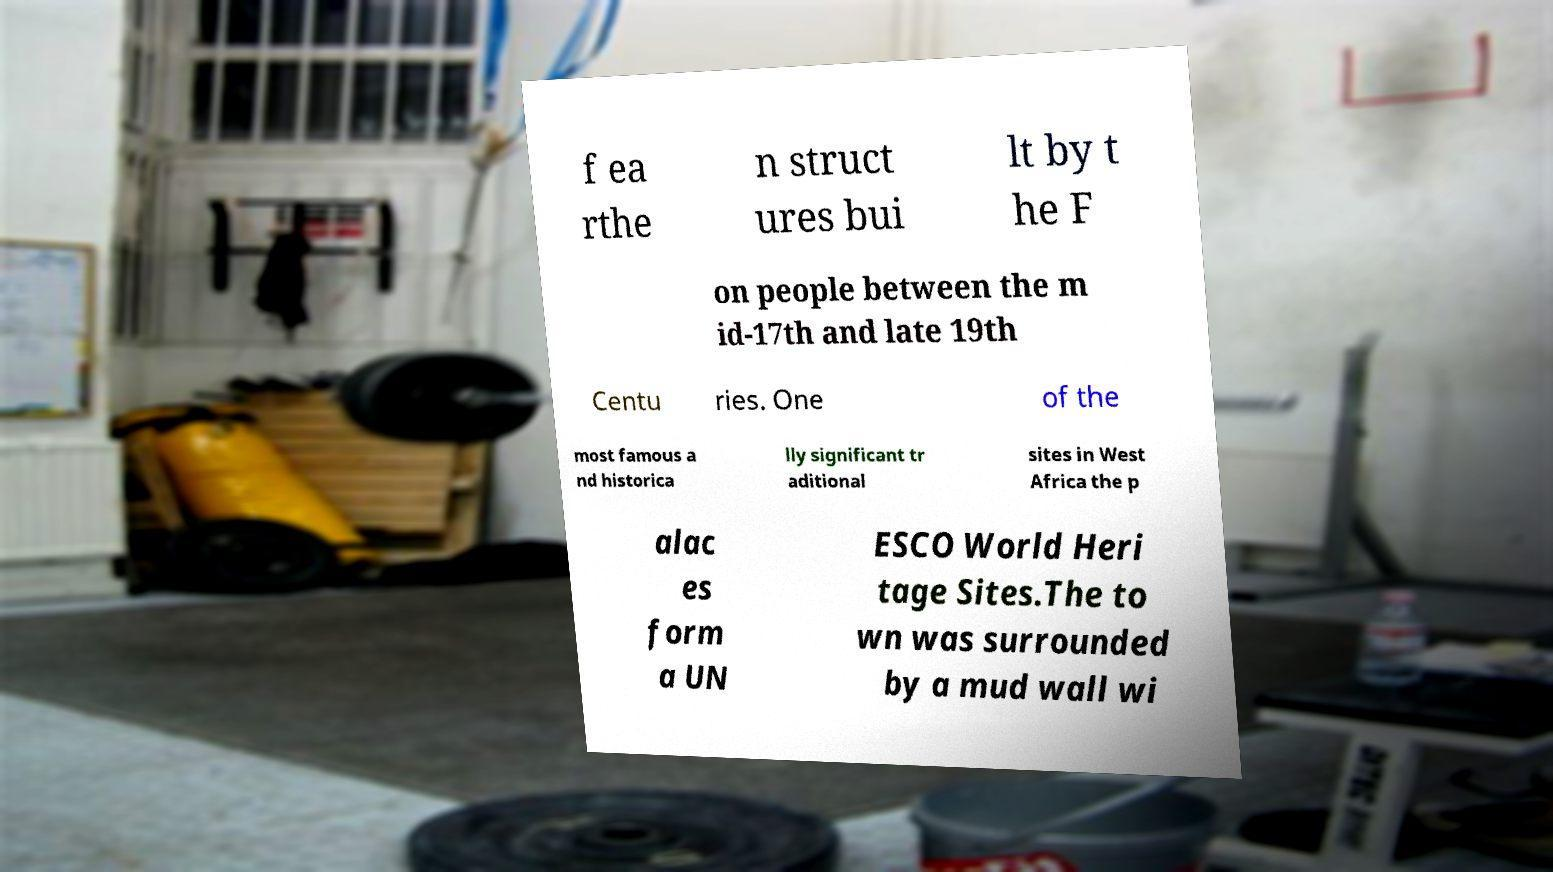Please identify and transcribe the text found in this image. f ea rthe n struct ures bui lt by t he F on people between the m id-17th and late 19th Centu ries. One of the most famous a nd historica lly significant tr aditional sites in West Africa the p alac es form a UN ESCO World Heri tage Sites.The to wn was surrounded by a mud wall wi 